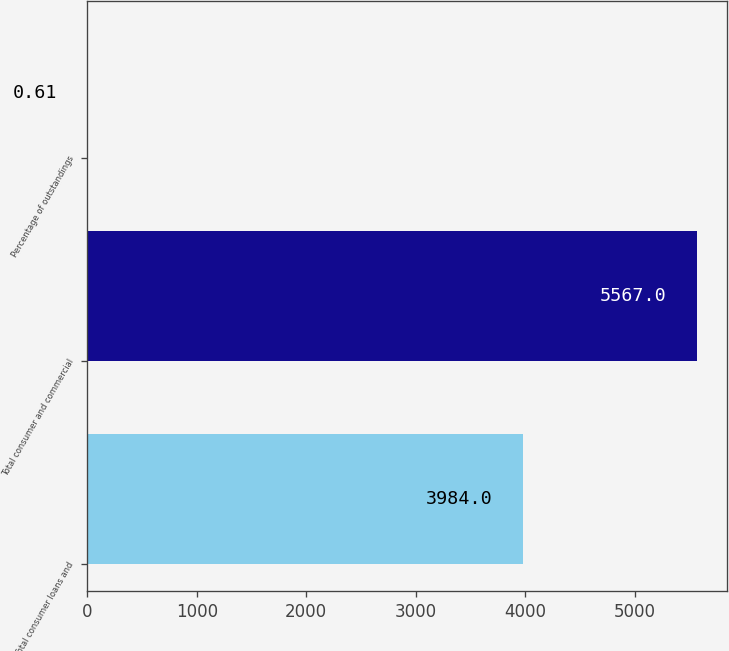<chart> <loc_0><loc_0><loc_500><loc_500><bar_chart><fcel>Total consumer loans and<fcel>Total consumer and commercial<fcel>Percentage of outstandings<nl><fcel>3984<fcel>5567<fcel>0.61<nl></chart> 